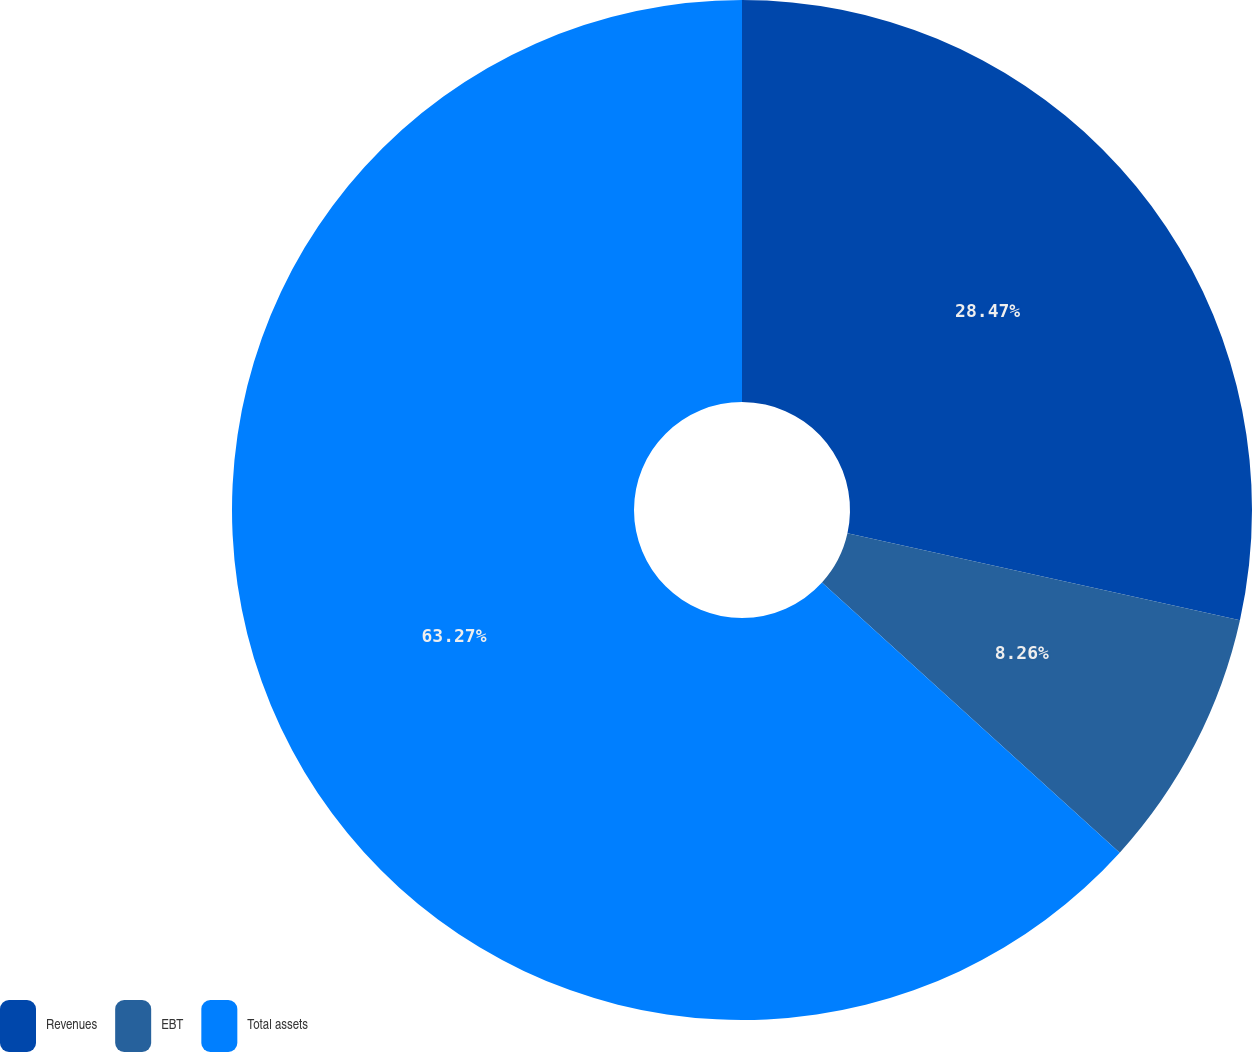<chart> <loc_0><loc_0><loc_500><loc_500><pie_chart><fcel>Revenues<fcel>EBT<fcel>Total assets<nl><fcel>28.47%<fcel>8.26%<fcel>63.28%<nl></chart> 